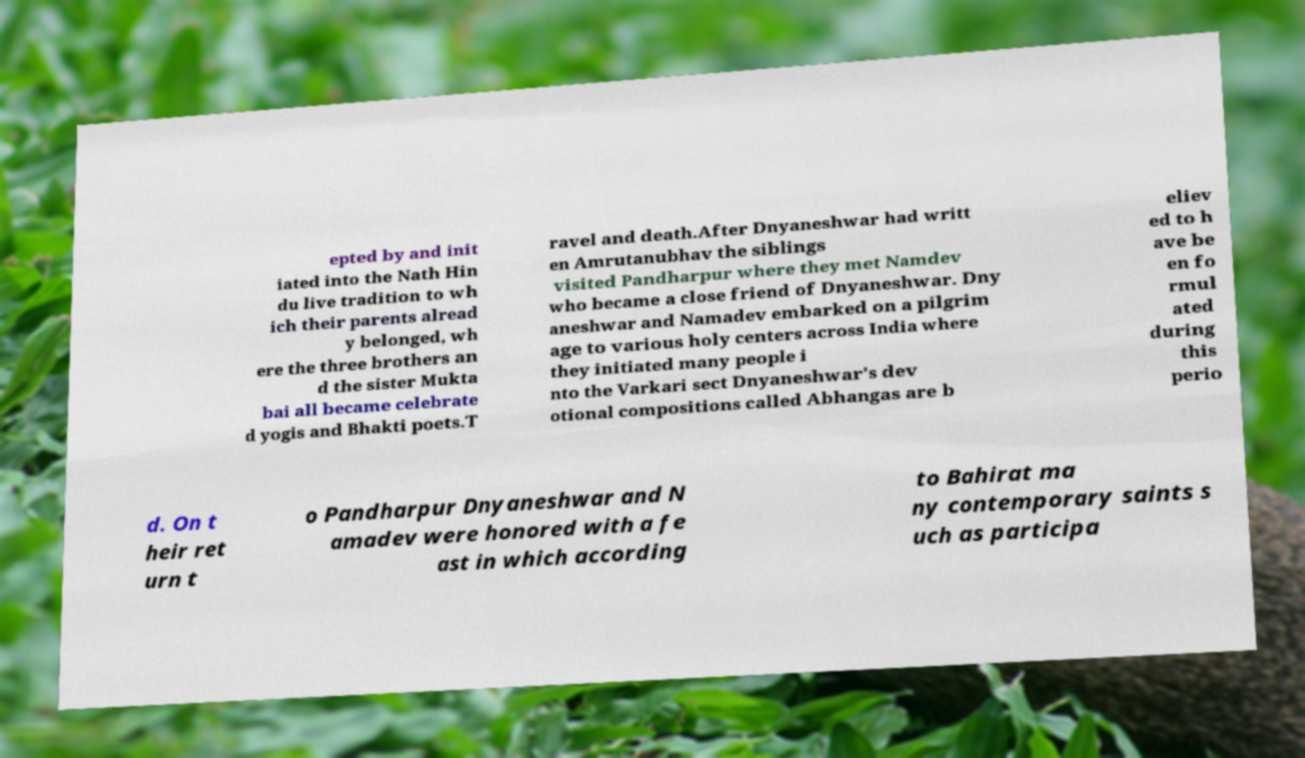I need the written content from this picture converted into text. Can you do that? epted by and init iated into the Nath Hin du live tradition to wh ich their parents alread y belonged, wh ere the three brothers an d the sister Mukta bai all became celebrate d yogis and Bhakti poets.T ravel and death.After Dnyaneshwar had writt en Amrutanubhav the siblings visited Pandharpur where they met Namdev who became a close friend of Dnyaneshwar. Dny aneshwar and Namadev embarked on a pilgrim age to various holy centers across India where they initiated many people i nto the Varkari sect Dnyaneshwar's dev otional compositions called Abhangas are b eliev ed to h ave be en fo rmul ated during this perio d. On t heir ret urn t o Pandharpur Dnyaneshwar and N amadev were honored with a fe ast in which according to Bahirat ma ny contemporary saints s uch as participa 